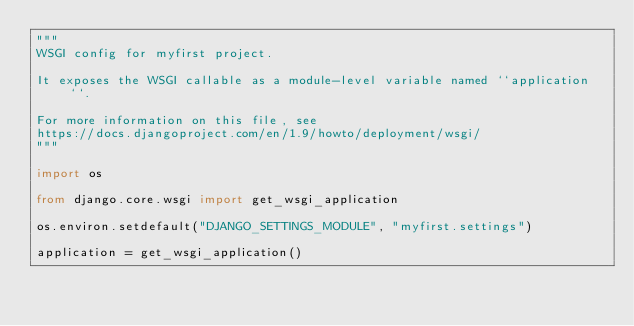<code> <loc_0><loc_0><loc_500><loc_500><_Python_>"""
WSGI config for myfirst project.

It exposes the WSGI callable as a module-level variable named ``application``.

For more information on this file, see
https://docs.djangoproject.com/en/1.9/howto/deployment/wsgi/
"""

import os

from django.core.wsgi import get_wsgi_application

os.environ.setdefault("DJANGO_SETTINGS_MODULE", "myfirst.settings")

application = get_wsgi_application()
</code> 